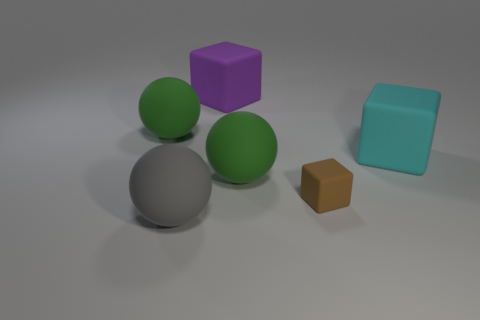Add 4 cyan blocks. How many objects exist? 10 Subtract all big cubes. How many cubes are left? 1 Subtract 3 balls. How many balls are left? 0 Subtract all gray spheres. How many spheres are left? 2 Subtract 0 green blocks. How many objects are left? 6 Subtract all gray balls. Subtract all gray blocks. How many balls are left? 2 Subtract all purple blocks. How many blue balls are left? 0 Subtract all gray matte balls. Subtract all small matte things. How many objects are left? 4 Add 1 brown matte things. How many brown matte things are left? 2 Add 1 big gray spheres. How many big gray spheres exist? 2 